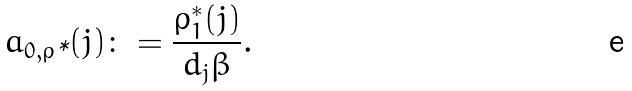Convert formula to latex. <formula><loc_0><loc_0><loc_500><loc_500>a _ { 0 , \varrho { \text {*} } } ( j ) \colon = \frac { \varrho _ { 1 } ^ { * } ( j ) } { d _ { j } \beta } .</formula> 